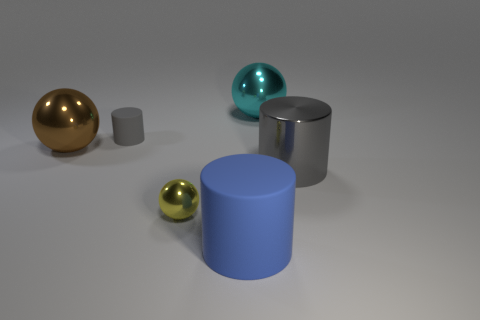Subtract 1 balls. How many balls are left? 2 Add 3 cyan matte balls. How many objects exist? 9 Add 4 tiny cylinders. How many tiny cylinders are left? 5 Add 6 large brown metal spheres. How many large brown metal spheres exist? 7 Subtract 0 cyan cubes. How many objects are left? 6 Subtract all large yellow cubes. Subtract all small spheres. How many objects are left? 5 